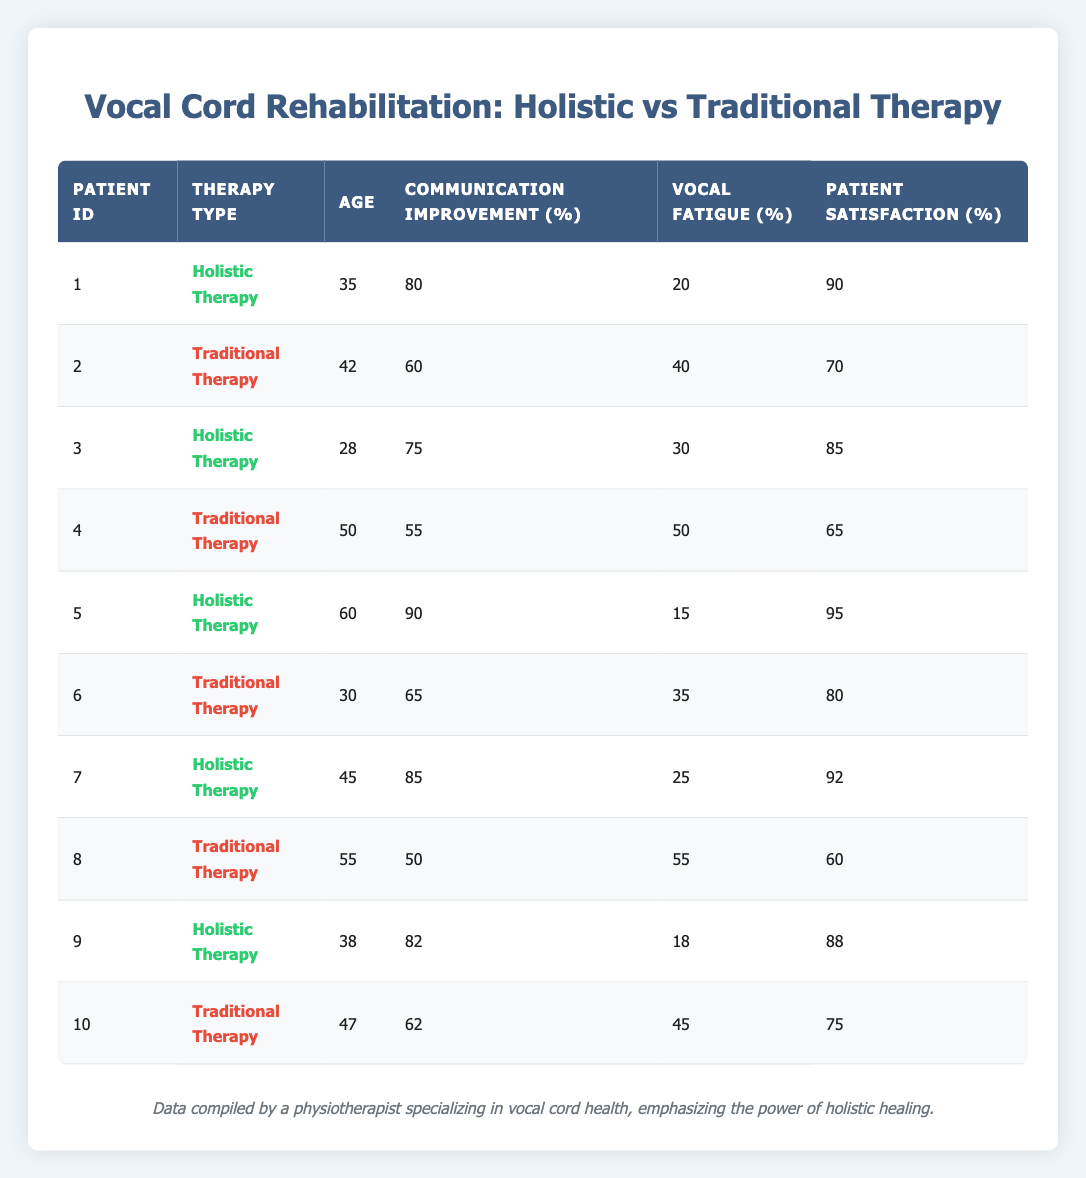What is the communication improvement percentage for the patient undergoing holistic therapy with patient ID 5? Referring to the table, for patient ID 5, the therapy type is "Holistic Therapy", and the communication improvement percentage listed is 90.
Answer: 90 What is the average patient satisfaction score for traditional therapy patients? The traditional therapy patients (IDs 2, 4, 6, 8, 10) have satisfaction scores of 70, 65, 80, 60, and 75. Adding these gives a total of 350, and dividing by 5 (the number of traditional therapy patients) gives an average of 350/5 = 70.
Answer: 70 Is the vocal fatigue percentage lower in holistic therapy compared to traditional therapy? For holistic therapy, the vocal fatigue percentages are 20, 30, 15, 25, and 18, averaging 21.6. For traditional therapy, the percentages are 40, 50, 35, 55, and 45, averaging 45. Since 21.6 is lower than 45, holistic therapy does show lower vocal fatigue.
Answer: Yes Who had the highest communication improvement score, and what was the value? Looking through the communication improvement scores, patient ID 5 has the highest score of 90. Checking all the entries, no other patient exceeds this value.
Answer: Patient ID 5, 90 What is the difference in patient satisfaction between the best and worst scores? The highest patient satisfaction score from holistic therapy is 95 (patient ID 5), and the lowest from traditional therapy is 60 (patient ID 8). The difference is 95 - 60 = 35.
Answer: 35 What therapy type do patients aged 55 or older prefer based on satisfaction scores? For patients aged 55 or older, there is one holistic therapy patient (patient ID 5) with a satisfaction score of 95 and one traditional therapy patient (patient ID 8) with a score of 60. The higher score among these indicates a preference for holistic therapy based on satisfaction.
Answer: Holistic Therapy Are there more patients undergoing holistic therapy or traditional therapy in this sample? Counting the entries, there are 5 patients for holistic therapy (IDs 1, 3, 5, 7, 9) and 5 for traditional therapy (IDs 2, 4, 6, 8, 10). Therefore, they are equal in number.
Answer: Equal What is the average communication improvement for all patients? Summing all communication improvements: 80 + 60 + 75 + 55 + 90 + 65 + 85 + 50 + 82 + 62 =  862. With 10 patients, the average is 862/10 = 86.2.
Answer: 86.2 Which patient had the lowest vocal fatigue score and what was it? The lowest vocal fatigue percentage in the table is 15, found in patient ID 5 who underwent holistic therapy. Confirming against all entries shows this is the lowest value.
Answer: Patient ID 5, 15 